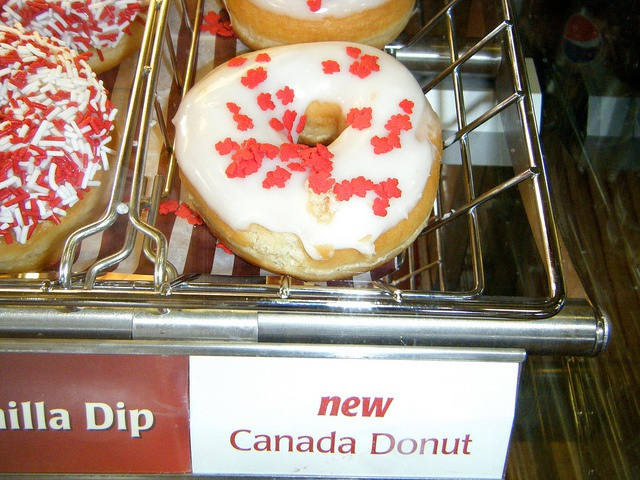Describe the objects in this image and their specific colors. I can see donut in brown, ivory, salmon, and tan tones, donut in brown, lightgray, salmon, and tan tones, donut in brown, orange, tan, olive, and lightgray tones, and donut in brown, darkgray, and lightgray tones in this image. 